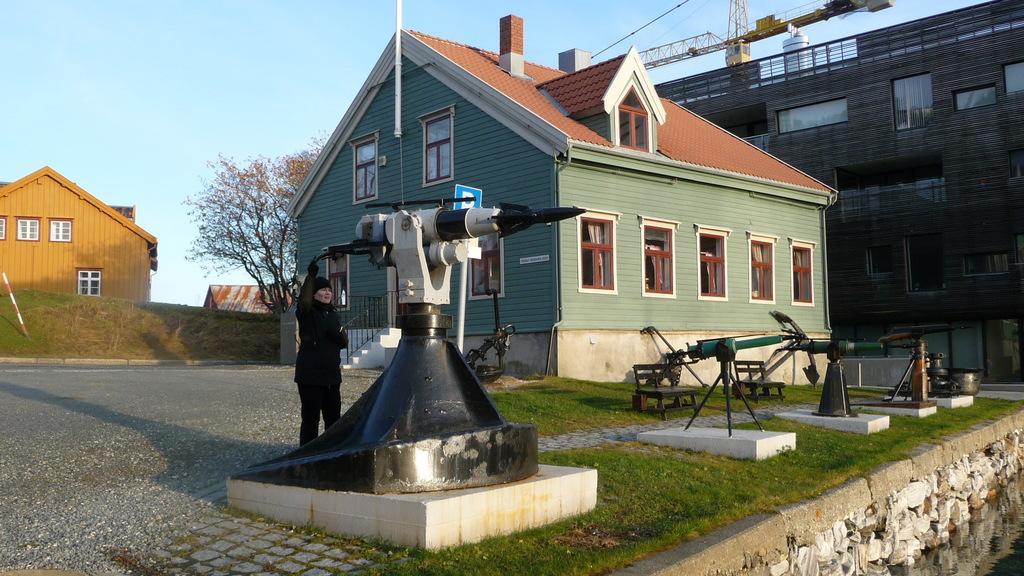Please provide a concise description of this image. In this picture we can see a woman, beside to her we can find few telescopes, buildings, in the background we can see a tree and a crane. 